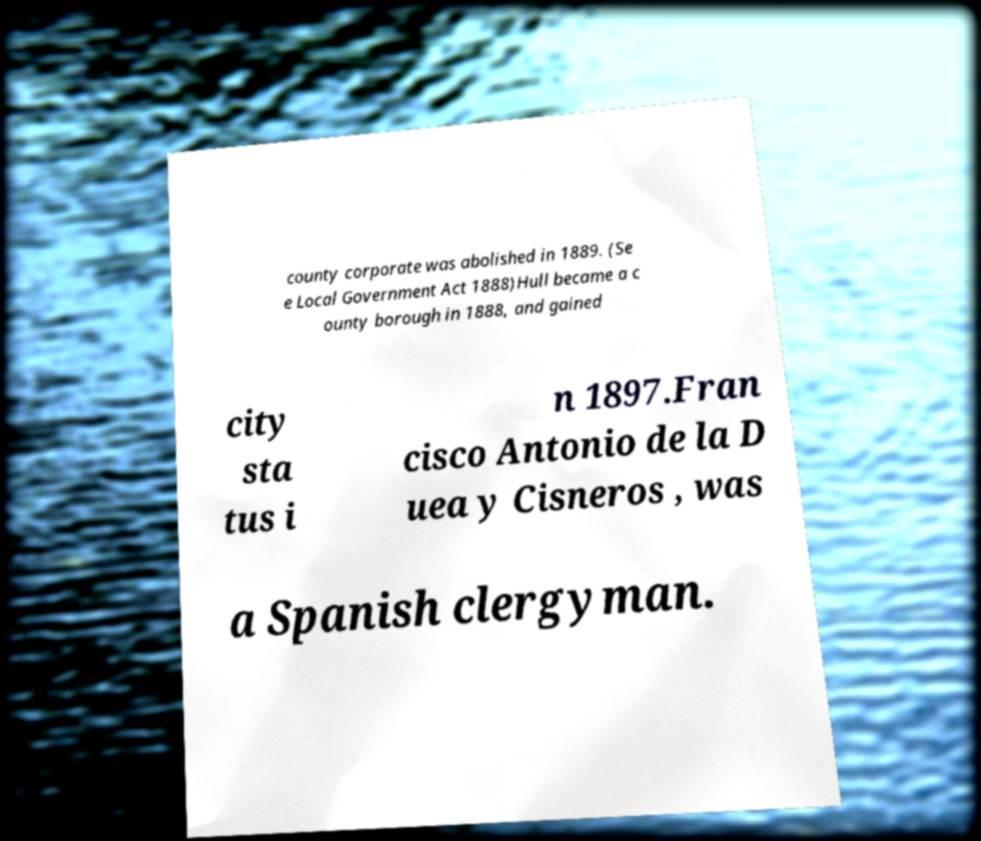Please identify and transcribe the text found in this image. county corporate was abolished in 1889. (Se e Local Government Act 1888)Hull became a c ounty borough in 1888, and gained city sta tus i n 1897.Fran cisco Antonio de la D uea y Cisneros , was a Spanish clergyman. 